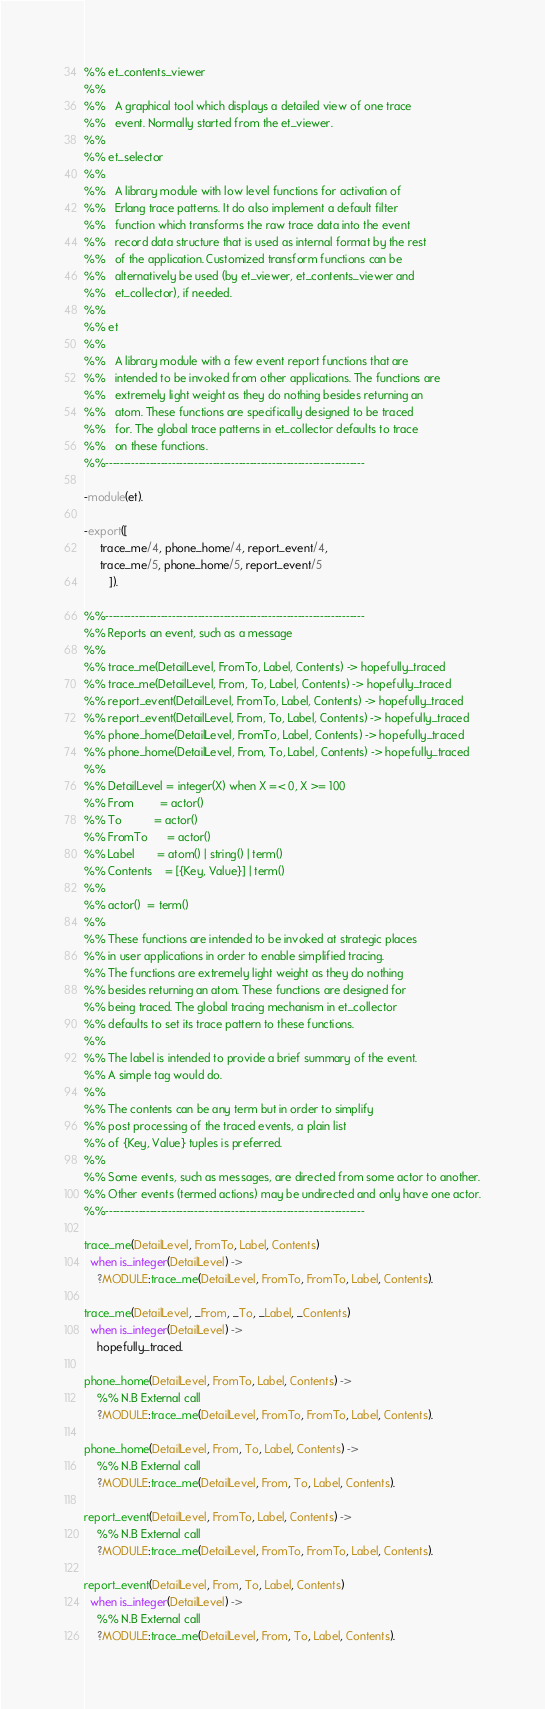Convert code to text. <code><loc_0><loc_0><loc_500><loc_500><_Erlang_>%% et_contents_viewer
%%
%%   A graphical tool which displays a detailed view of one trace
%%   event. Normally started from the et_viewer.
%%   
%% et_selector
%%
%%   A library module with low level functions for activation of
%%   Erlang trace patterns. It do also implement a default filter
%%   function which transforms the raw trace data into the event
%%   record data structure that is used as internal format by the rest
%%   of the application. Customized transform functions can be
%%   alternatively be used (by et_viewer, et_contents_viewer and
%%   et_collector), if needed.
%%   
%% et
%%
%%   A library module with a few event report functions that are
%%   intended to be invoked from other applications. The functions are
%%   extremely light weight as they do nothing besides returning an
%%   atom. These functions are specifically designed to be traced
%%   for. The global trace patterns in et_collector defaults to trace
%%   on these functions.
%%----------------------------------------------------------------------

-module(et).

-export([
	 trace_me/4, phone_home/4, report_event/4,
	 trace_me/5, phone_home/5, report_event/5
        ]).

%%----------------------------------------------------------------------
%% Reports an event, such as a message
%%
%% trace_me(DetailLevel, FromTo, Label, Contents) -> hopefully_traced
%% trace_me(DetailLevel, From, To, Label, Contents) -> hopefully_traced
%% report_event(DetailLevel, FromTo, Label, Contents) -> hopefully_traced
%% report_event(DetailLevel, From, To, Label, Contents) -> hopefully_traced
%% phone_home(DetailLevel, FromTo, Label, Contents) -> hopefully_traced
%% phone_home(DetailLevel, From, To, Label, Contents) -> hopefully_traced
%%
%% DetailLevel = integer(X) when X =< 0, X >= 100
%% From        = actor()
%% To          = actor()
%% FromTo      = actor()
%% Label       = atom() | string() | term()
%% Contents    = [{Key, Value}] | term()
%%
%% actor()  = term()
%%
%% These functions are intended to be invoked at strategic places
%% in user applications in order to enable simplified tracing.
%% The functions are extremely light weight as they do nothing
%% besides returning an atom. These functions are designed for
%% being traced. The global tracing mechanism in et_collector
%% defaults to set its trace pattern to these functions.
%%   
%% The label is intended to provide a brief summary of the event.
%% A simple tag would do.
%%
%% The contents can be any term but in order to simplify
%% post processing of the traced events, a plain list
%% of {Key, Value} tuples is preferred.
%%
%% Some events, such as messages, are directed from some actor to another.
%% Other events (termed actions) may be undirected and only have one actor.
%%----------------------------------------------------------------------

trace_me(DetailLevel, FromTo, Label, Contents)
  when is_integer(DetailLevel) ->
    ?MODULE:trace_me(DetailLevel, FromTo, FromTo, Label, Contents).

trace_me(DetailLevel, _From, _To, _Label, _Contents)
  when is_integer(DetailLevel) ->
    hopefully_traced.

phone_home(DetailLevel, FromTo, Label, Contents) ->
    %% N.B External call
    ?MODULE:trace_me(DetailLevel, FromTo, FromTo, Label, Contents).

phone_home(DetailLevel, From, To, Label, Contents) ->
    %% N.B External call
    ?MODULE:trace_me(DetailLevel, From, To, Label, Contents).

report_event(DetailLevel, FromTo, Label, Contents) ->
    %% N.B External call
    ?MODULE:trace_me(DetailLevel, FromTo, FromTo, Label, Contents).

report_event(DetailLevel, From, To, Label, Contents)
  when is_integer(DetailLevel) ->
    %% N.B External call
    ?MODULE:trace_me(DetailLevel, From, To, Label, Contents).

</code> 